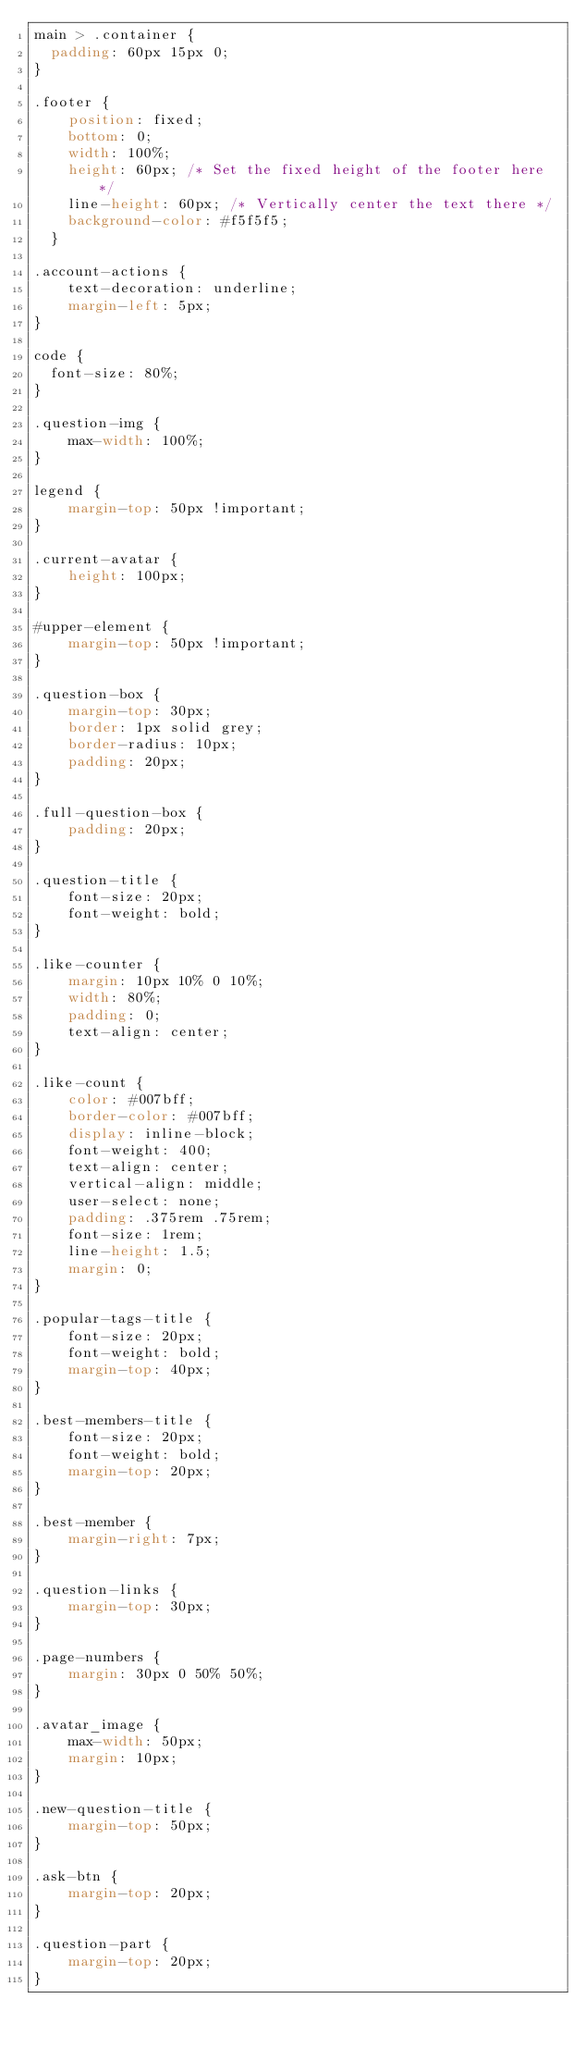Convert code to text. <code><loc_0><loc_0><loc_500><loc_500><_CSS_>main > .container {
  padding: 60px 15px 0;
}

.footer {
    position: fixed;
    bottom: 0;
    width: 100%;
    height: 60px; /* Set the fixed height of the footer here */
    line-height: 60px; /* Vertically center the text there */
    background-color: #f5f5f5;
  }

.account-actions {
    text-decoration: underline;
    margin-left: 5px;
}

code {
  font-size: 80%;
}

.question-img {
    max-width: 100%;
}

legend {
    margin-top: 50px !important;
}

.current-avatar {
    height: 100px;
}

#upper-element {
    margin-top: 50px !important;
}

.question-box {
    margin-top: 30px;
    border: 1px solid grey;
    border-radius: 10px;
    padding: 20px;
}

.full-question-box {
    padding: 20px;
}

.question-title {
    font-size: 20px;
    font-weight: bold;
}

.like-counter {
    margin: 10px 10% 0 10%;
    width: 80%;
    padding: 0;
    text-align: center;
}

.like-count {
    color: #007bff;
    border-color: #007bff;
    display: inline-block;
    font-weight: 400;
    text-align: center;
    vertical-align: middle;
    user-select: none;
    padding: .375rem .75rem;
    font-size: 1rem;
    line-height: 1.5;
    margin: 0;
}

.popular-tags-title {
    font-size: 20px;
    font-weight: bold;
    margin-top: 40px;
}

.best-members-title {
    font-size: 20px;
    font-weight: bold;
    margin-top: 20px;
}

.best-member {
    margin-right: 7px;
}

.question-links {
    margin-top: 30px;
}

.page-numbers {
    margin: 30px 0 50% 50%;
}

.avatar_image {
    max-width: 50px;
    margin: 10px;
}

.new-question-title {
    margin-top: 50px;
}

.ask-btn {
    margin-top: 20px;
}

.question-part {
    margin-top: 20px;
}</code> 